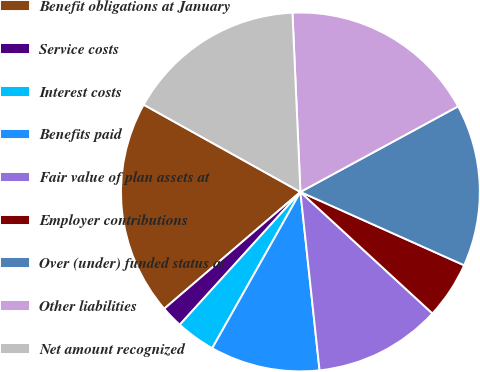Convert chart to OTSL. <chart><loc_0><loc_0><loc_500><loc_500><pie_chart><fcel>Benefit obligations at January<fcel>Service costs<fcel>Interest costs<fcel>Benefits paid<fcel>Fair value of plan assets at<fcel>Employer contributions<fcel>Over (under) funded status at<fcel>Other liabilities<fcel>Net amount recognized<nl><fcel>19.37%<fcel>1.98%<fcel>3.56%<fcel>9.88%<fcel>11.46%<fcel>5.14%<fcel>14.62%<fcel>17.79%<fcel>16.21%<nl></chart> 